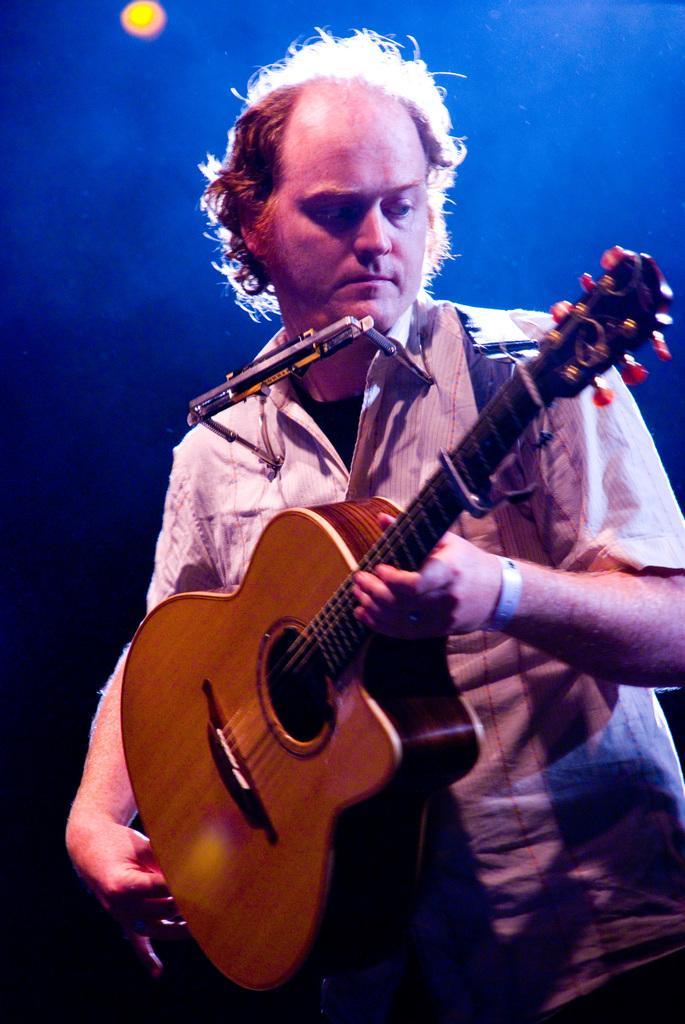In one or two sentences, can you explain what this image depicts? There is a man who is playing guitar and this is light. 